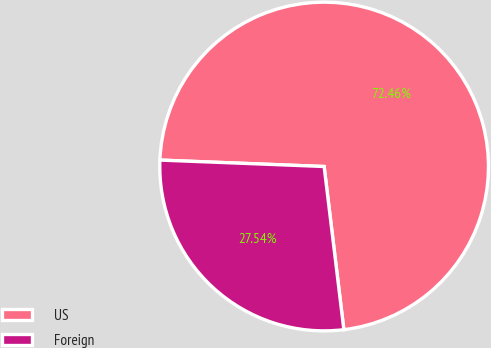Convert chart. <chart><loc_0><loc_0><loc_500><loc_500><pie_chart><fcel>US<fcel>Foreign<nl><fcel>72.46%<fcel>27.54%<nl></chart> 